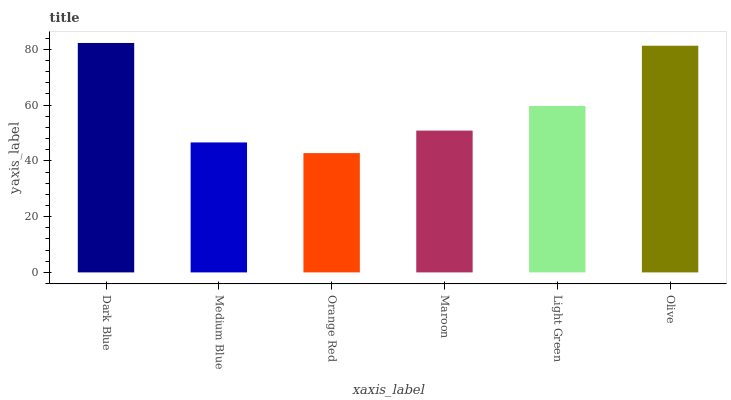Is Medium Blue the minimum?
Answer yes or no. No. Is Medium Blue the maximum?
Answer yes or no. No. Is Dark Blue greater than Medium Blue?
Answer yes or no. Yes. Is Medium Blue less than Dark Blue?
Answer yes or no. Yes. Is Medium Blue greater than Dark Blue?
Answer yes or no. No. Is Dark Blue less than Medium Blue?
Answer yes or no. No. Is Light Green the high median?
Answer yes or no. Yes. Is Maroon the low median?
Answer yes or no. Yes. Is Olive the high median?
Answer yes or no. No. Is Medium Blue the low median?
Answer yes or no. No. 